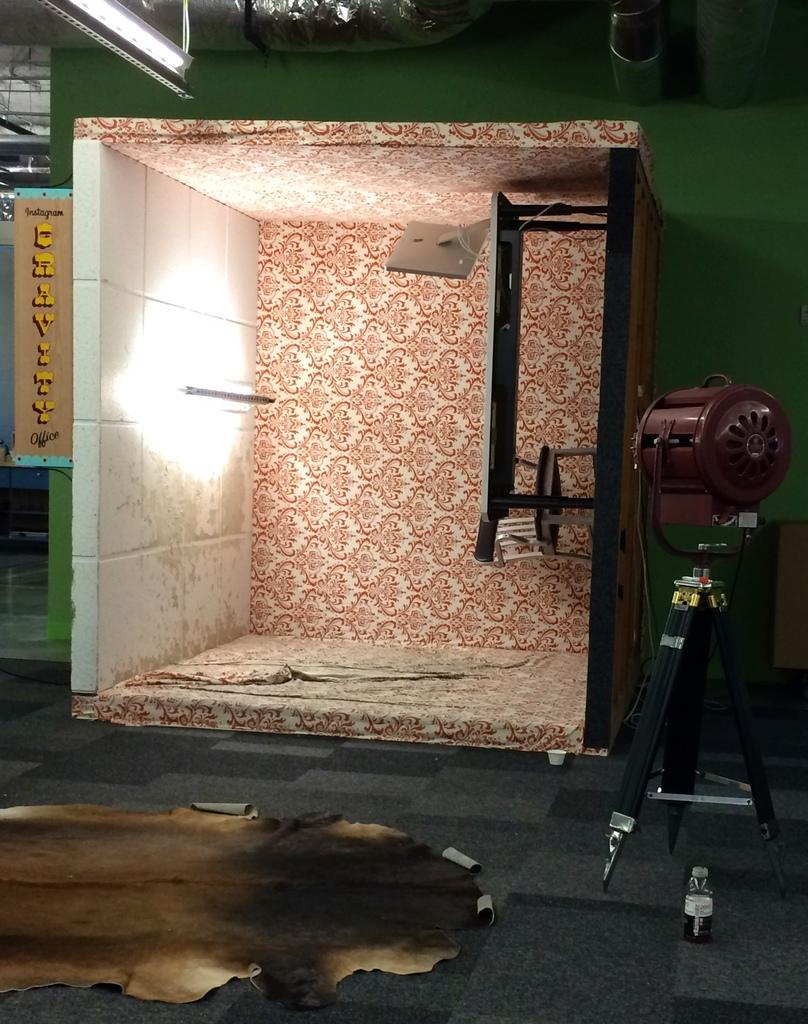What is the main object in the image? There is a tripod stand in the image. What is on the tripod stand? A brown-colored light is on the tripod stand. What piece of furniture is present in the image? There is a table in the image. What object is on the table? There is a bottle on the table. What color is the wall in the background? The wall in the background is green in color. What type of meeting is taking place in the image? There is no indication of a meeting in the image; it only shows a tripod stand, a brown-colored light, a table, a bottle, and a green wall in the background. 